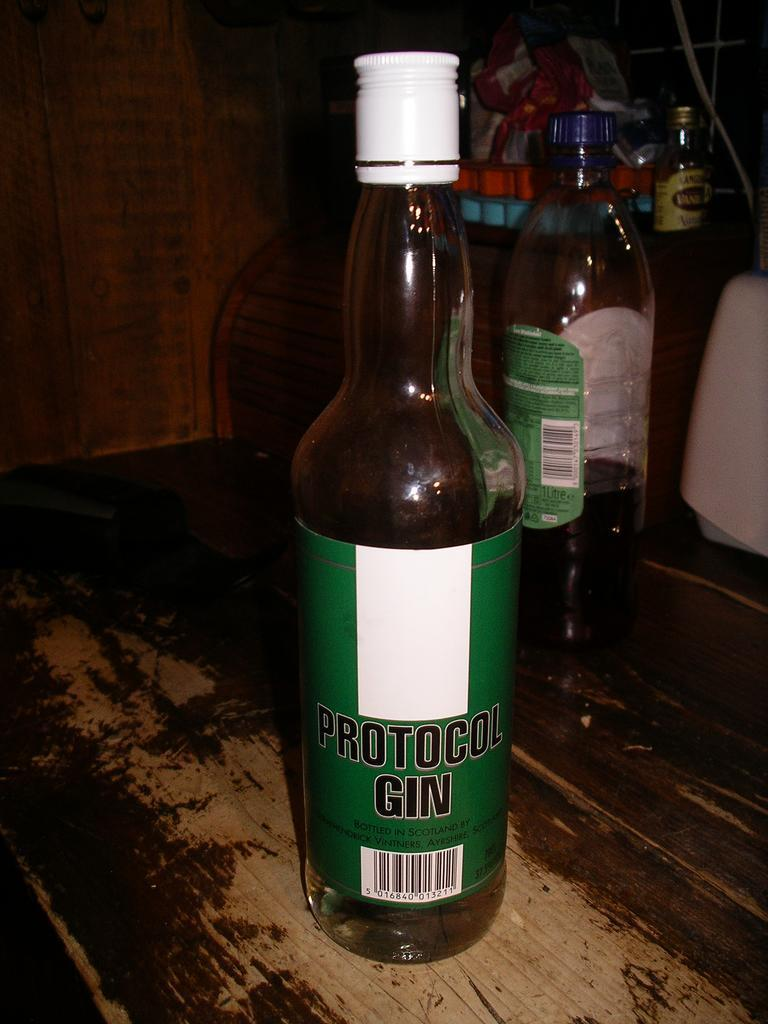<image>
Describe the image concisely. the word protocol gin that is on a bottle 